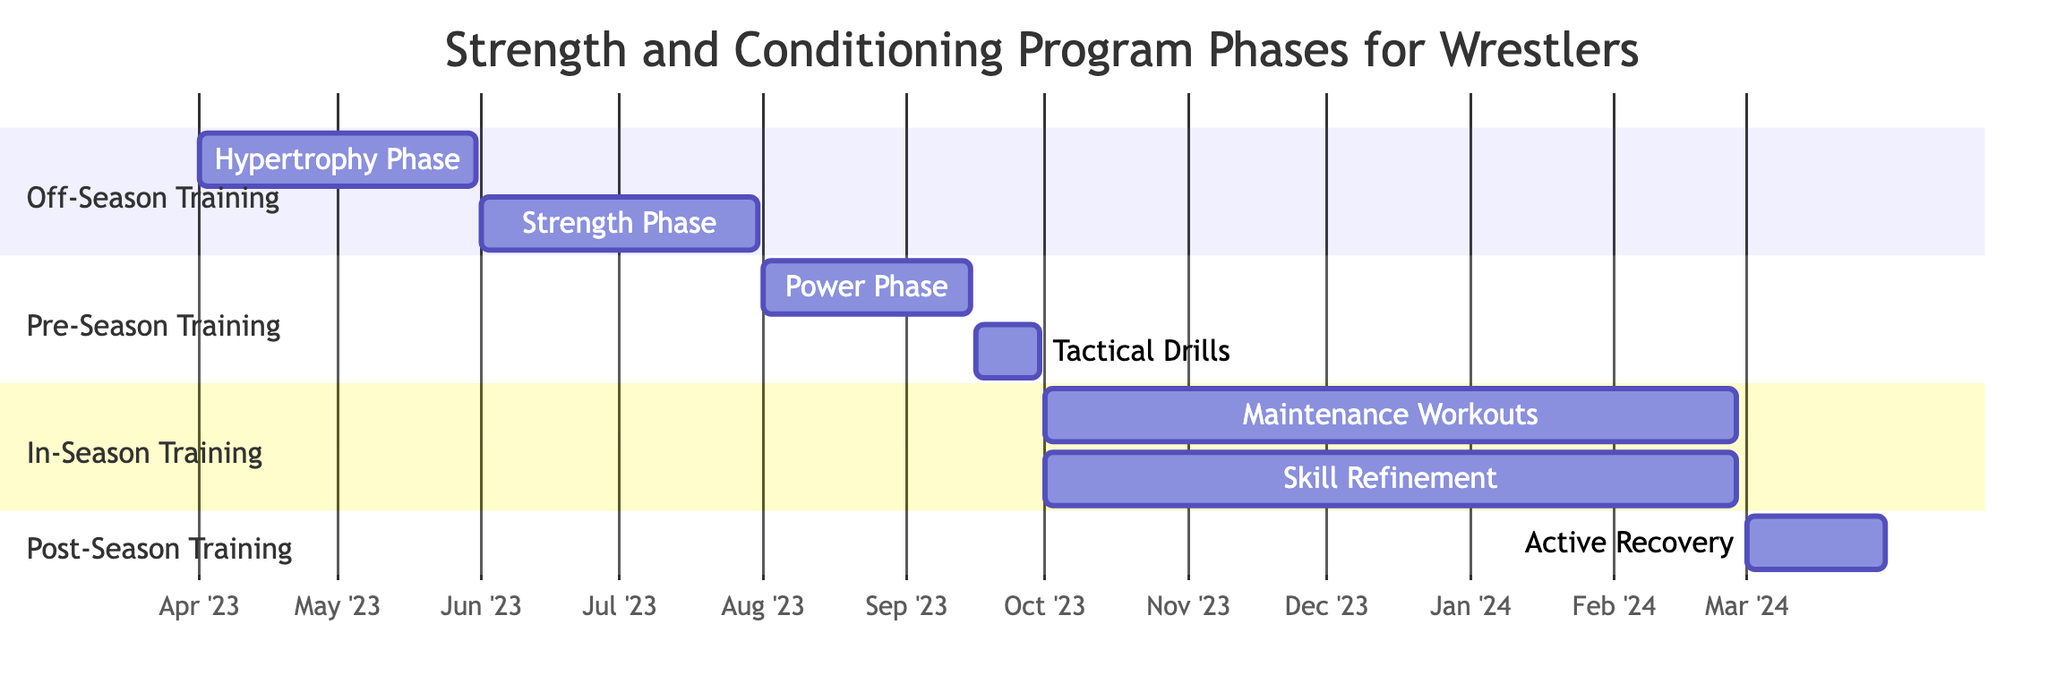What is the first phase in the Off-Season Training section? The Off-Season Training section starts with the Hypertrophy Phase, which is the first activity listed.
Answer: Hypertrophy Phase How long does the Strength Phase last? The Strength Phase starts on June 1, 2023, and ends on July 31, 2023, which is a duration of two months.
Answer: 2 months What activities occur during the In-Season Training period? The In-Season Training section has two activities: Maintenance Workouts and Skill Refinement, both starting on October 1, 2023, and continuing until February 28, 2024.
Answer: Maintenance Workouts, Skill Refinement In which month does the Power Phase conclude? The Power Phase ends on September 15, 2023, which is in the month of September.
Answer: September How many phases are there in the entire training program? There are four distinct phases in the program: Off-Season Training, Pre-Season Training, In-Season Training, and Post-Season Training.
Answer: 4 What is the end date of the Active Recovery phase? The Active Recovery phase concludes on March 31, 2024, which is explicitly stated as its end date.
Answer: March 31, 2024 Which activities overlap in the In-Season Training section? In the In-Season Training section, both Maintenance Workouts and Skill Refinement overlap as they start on October 1, 2023, and end on February 28, 2024.
Answer: Maintenance Workouts, Skill Refinement What is the main focus of the Tactical Drills activity? The Tactical Drills activity focuses on simulating match conditions and refining wrestling tactics, as described in the diagram.
Answer: Simulate match conditions During which phase is explosive strength developed? Explosive strength development occurs during the Power Phase, which is specifically designed for that purpose.
Answer: Power Phase 